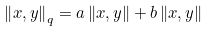Convert formula to latex. <formula><loc_0><loc_0><loc_500><loc_500>\left \| x , y \right \| _ { q } = a \left \| x , y \right \| + b \left \| x , y \right \|</formula> 